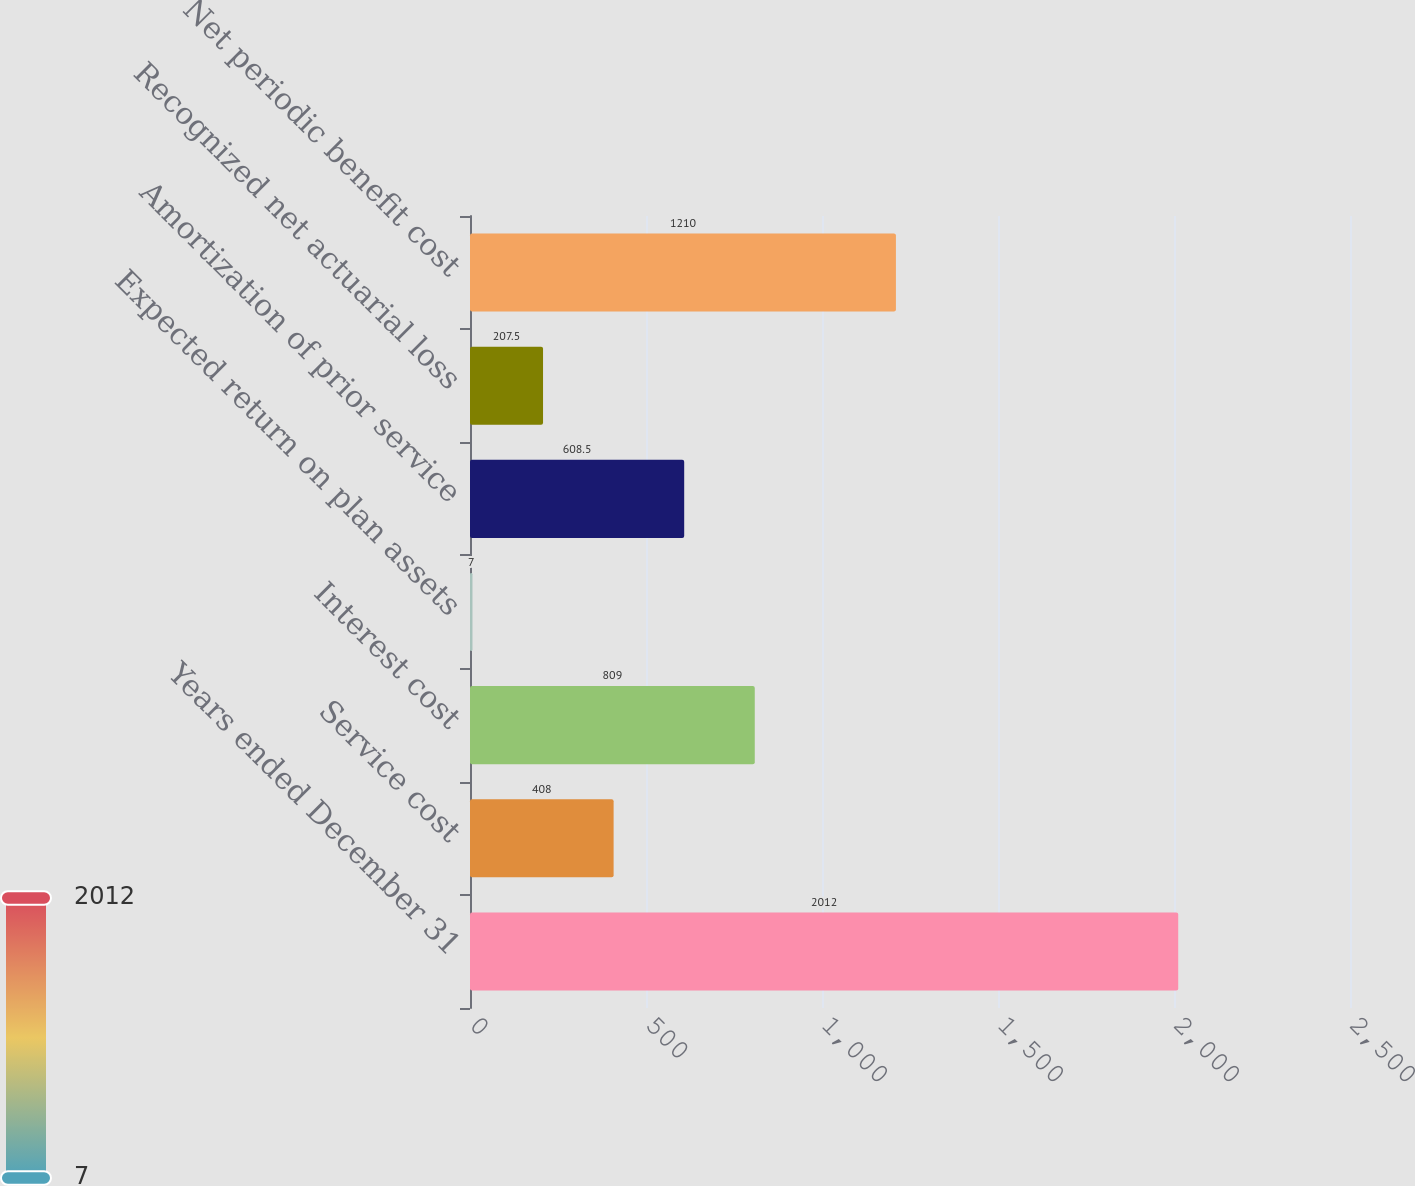Convert chart. <chart><loc_0><loc_0><loc_500><loc_500><bar_chart><fcel>Years ended December 31<fcel>Service cost<fcel>Interest cost<fcel>Expected return on plan assets<fcel>Amortization of prior service<fcel>Recognized net actuarial loss<fcel>Net periodic benefit cost<nl><fcel>2012<fcel>408<fcel>809<fcel>7<fcel>608.5<fcel>207.5<fcel>1210<nl></chart> 